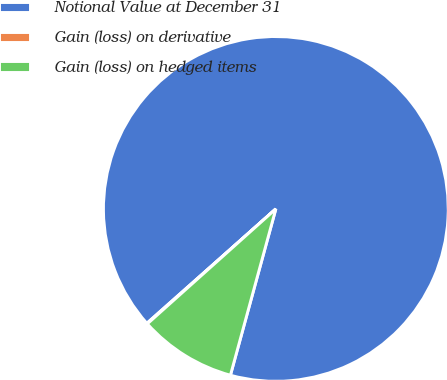Convert chart to OTSL. <chart><loc_0><loc_0><loc_500><loc_500><pie_chart><fcel>Notional Value at December 31<fcel>Gain (loss) on derivative<fcel>Gain (loss) on hedged items<nl><fcel>90.78%<fcel>0.07%<fcel>9.14%<nl></chart> 